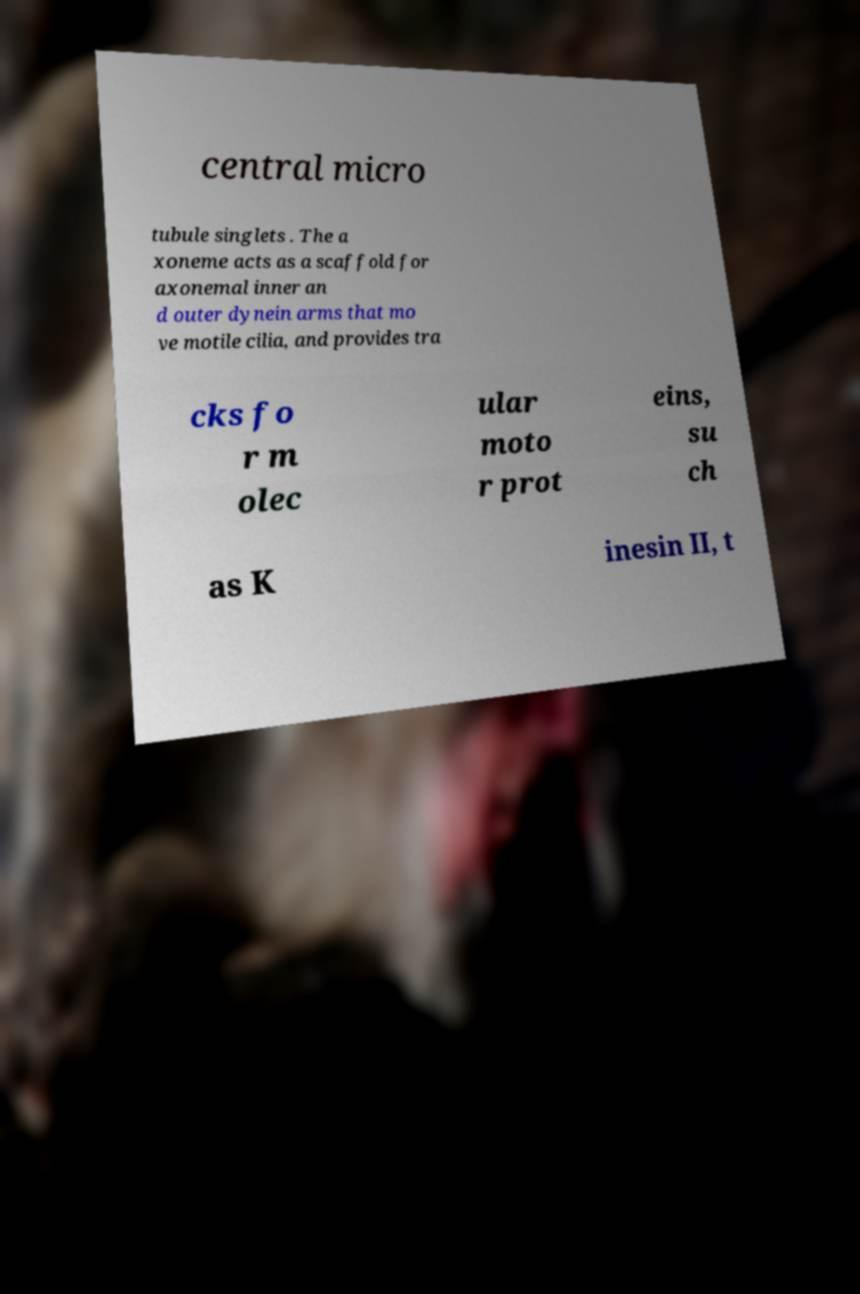Please read and relay the text visible in this image. What does it say? central micro tubule singlets . The a xoneme acts as a scaffold for axonemal inner an d outer dynein arms that mo ve motile cilia, and provides tra cks fo r m olec ular moto r prot eins, su ch as K inesin II, t 